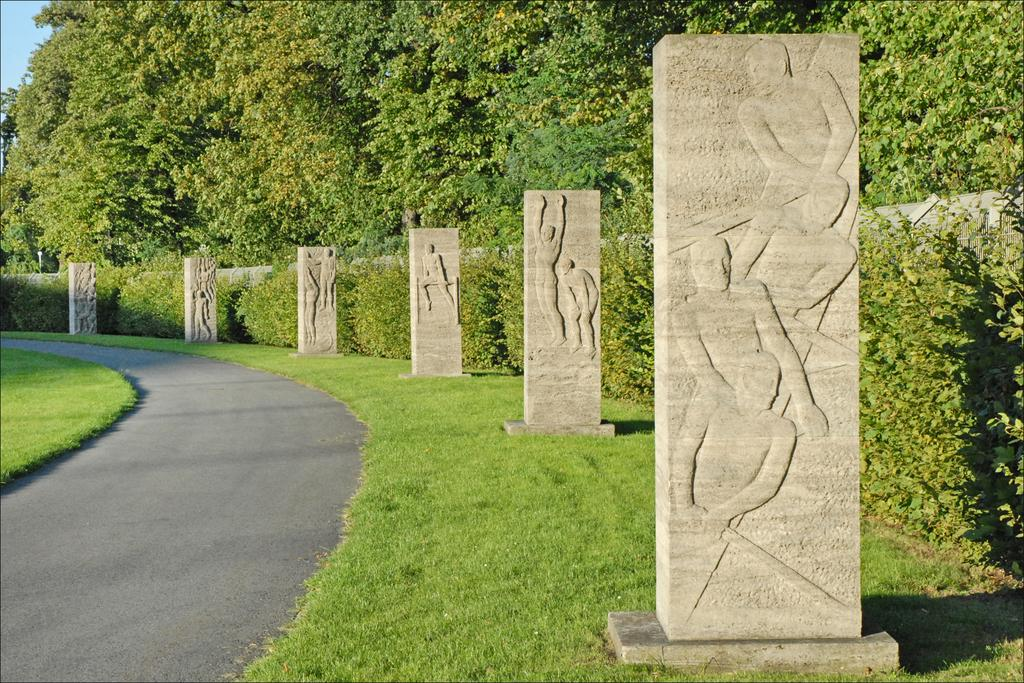What type of art can be seen on the stones in the image? The art designs on the stones in the image depict people. What can be seen in the background of the image? There are trees, plants, grass, a road, and the sky visible in the background of the image. How many different types of vegetation can be seen in the background? There are two types of vegetation visible in the background: trees and plants. How does the worm affect the art designs on the stones in the image? There are no worms present in the image, so it cannot affect the art designs on the stones. 